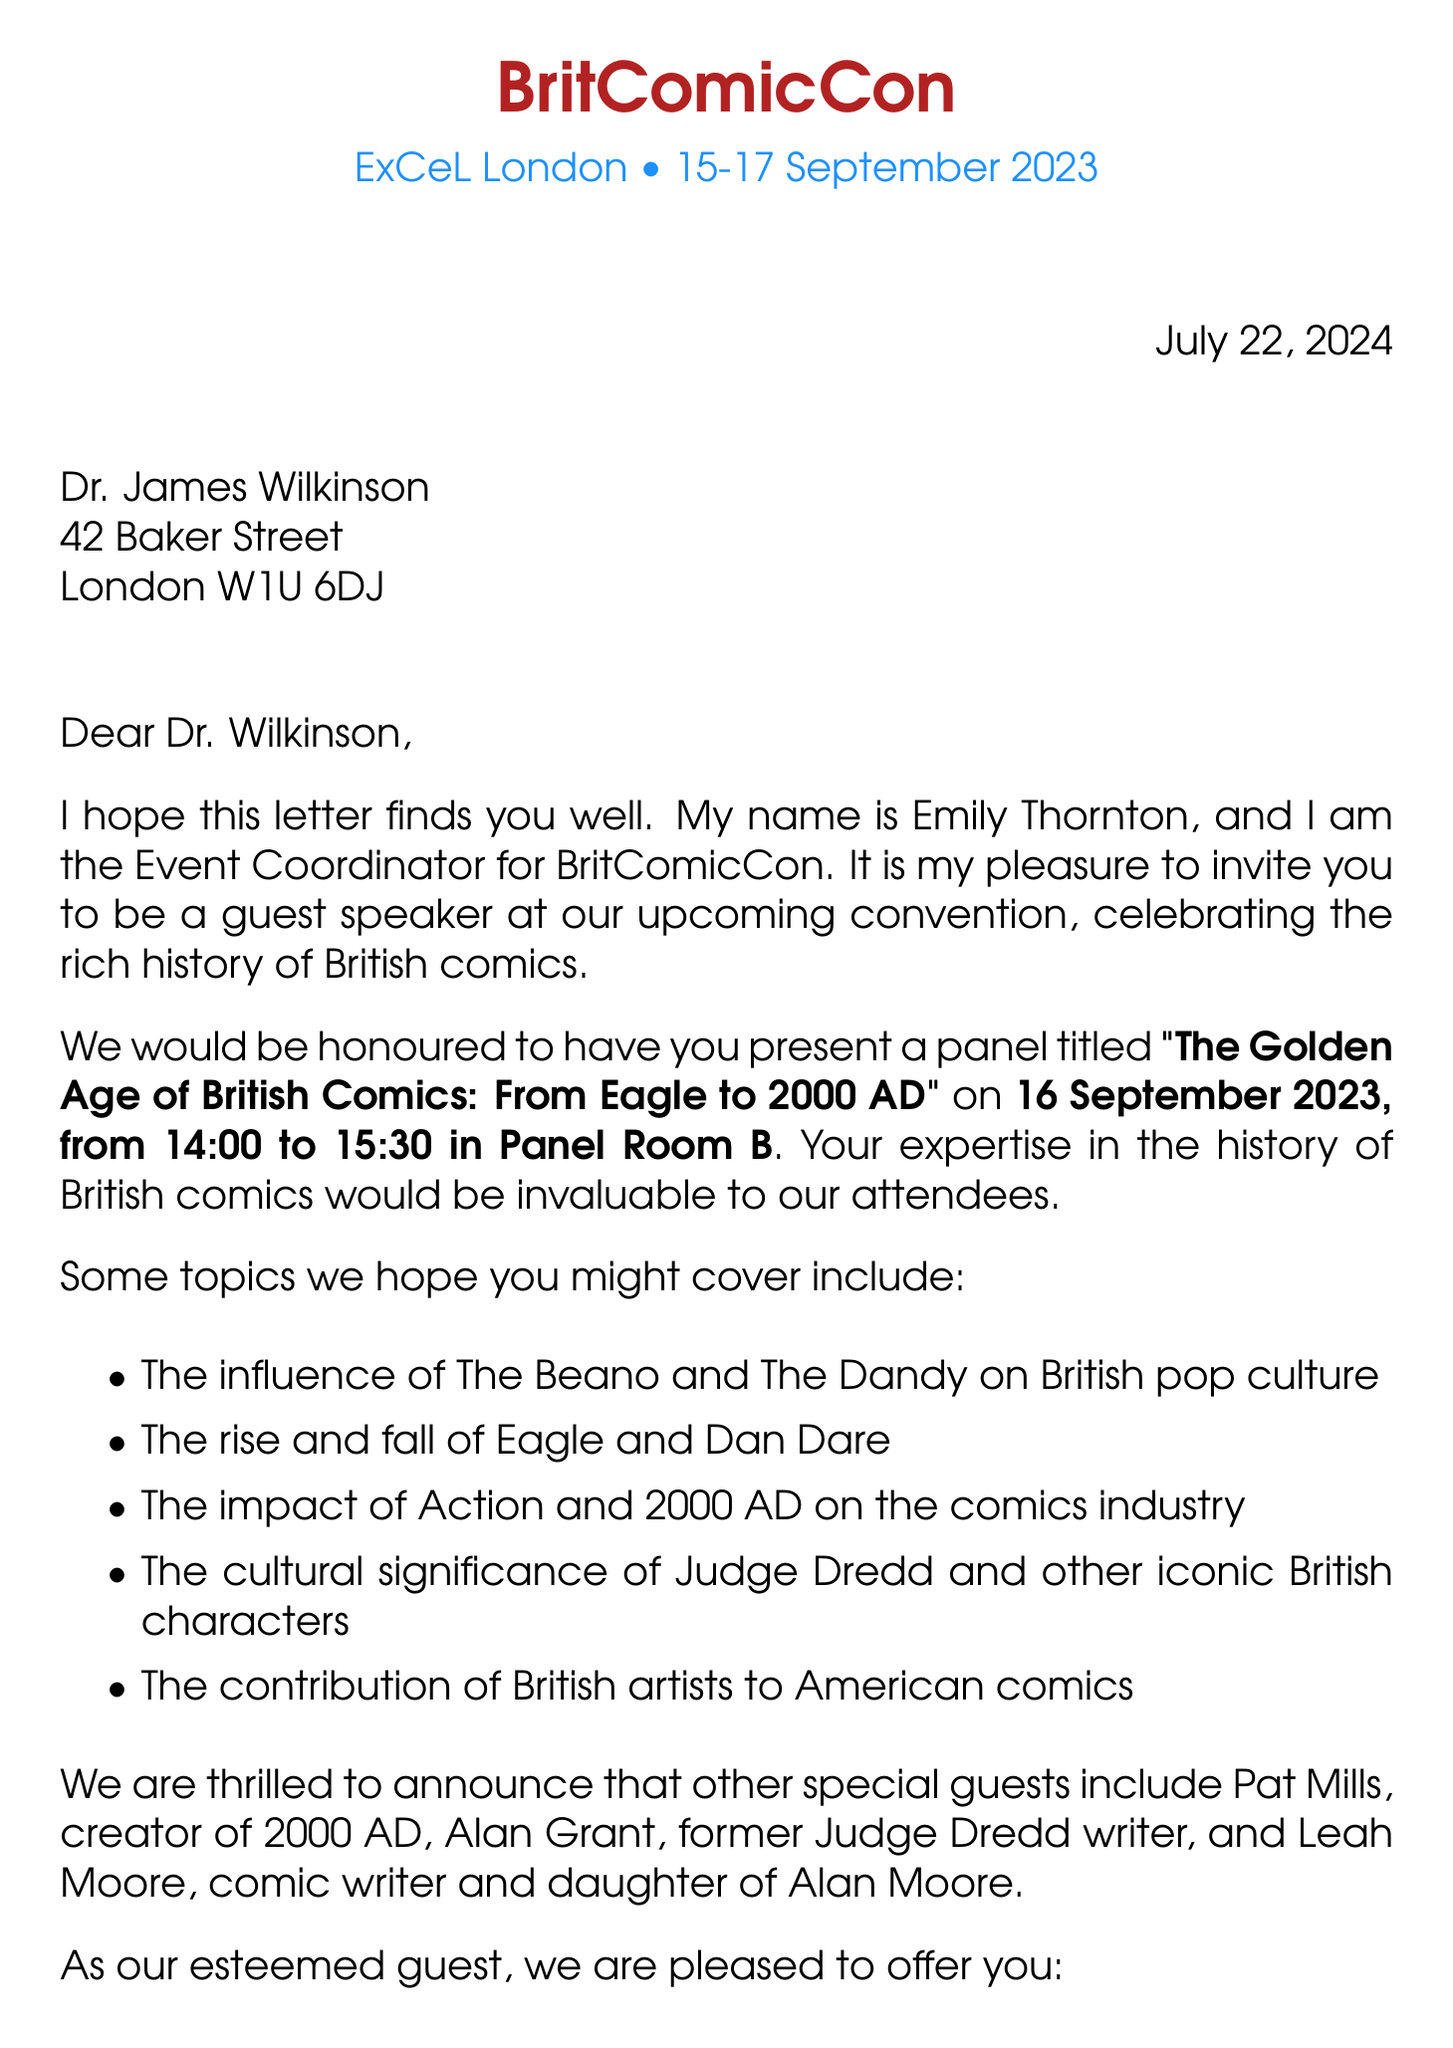What is the name of the event coordinator? The event coordinator is Emily Thornton, who is mentioned in the letter.
Answer: Emily Thornton What date is the panel scheduled for? The panel is scheduled for 16 September 2023 as stated in the invitation details.
Answer: 16 September 2023 What is the title of the panel? The title of the panel is given as "The Golden Age of British Comics: From Eagle to 2000 AD".
Answer: The Golden Age of British Comics: From Eagle to 2000 AD How long will the panel last? The panel is set to take place from 14:00 to 15:30, which is a duration of 1.5 hours.
Answer: 1.5 hours Who are some of the special guests? The letter lists several special guests, including Pat Mills, Alan Grant, and Leah Moore.
Answer: Pat Mills, Alan Grant, Leah Moore What hotel is offered for accommodation? Accommodation includes two nights at the Aloft London ExCeL, as mentioned in the offer.
Answer: Aloft London ExCeL What topics are suggested for the presentation? Suggested topics include the influence of The Beano, the rise of Eagle, and the impact of 2000 AD.
Answer: The influence of The Beano and The Dandy on British pop culture, the rise and fall of Eagle and Dan Dare, the impact of Action and 2000 AD on the comics industry, the cultural significance of Judge Dredd and other iconic British characters, the contribution of British artists like Brian Bolland and Dave Gibbons to American comics How many nights of accommodation are offered? The letter specifies that two nights of accommodation will be provided for the speaker.
Answer: Two nights Who should be contacted for confirmation? The letter advises contacting Sarah James for any questions or confirmation regarding the invitation.
Answer: Sarah James 